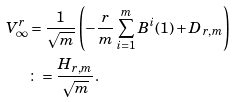<formula> <loc_0><loc_0><loc_500><loc_500>V ^ { r } _ { \infty } & = \frac { 1 } { \sqrt { m } } \left ( - \frac { r } { m } \sum _ { i = 1 } ^ { m } B ^ { i } ( 1 ) + D _ { r , m } \right ) \\ & \colon = \frac { H _ { r , m } } { \sqrt { m } } .</formula> 